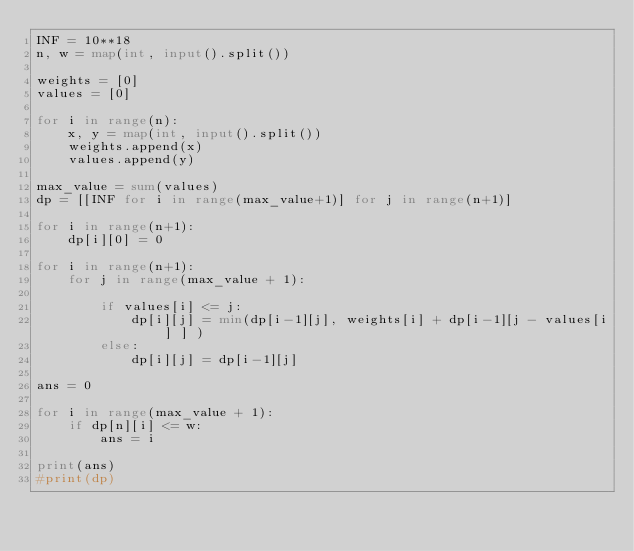<code> <loc_0><loc_0><loc_500><loc_500><_Python_>INF = 10**18
n, w = map(int, input().split())

weights = [0]
values = [0]

for i in range(n):
    x, y = map(int, input().split())
    weights.append(x)
    values.append(y)

max_value = sum(values)
dp = [[INF for i in range(max_value+1)] for j in range(n+1)]

for i in range(n+1):
    dp[i][0] = 0

for i in range(n+1):
    for j in range(max_value + 1):

        if values[i] <= j:
            dp[i][j] = min(dp[i-1][j], weights[i] + dp[i-1][j - values[i] ] )
        else:
            dp[i][j] = dp[i-1][j]

ans = 0

for i in range(max_value + 1):
    if dp[n][i] <= w:
        ans = i

print(ans)
#print(dp)</code> 